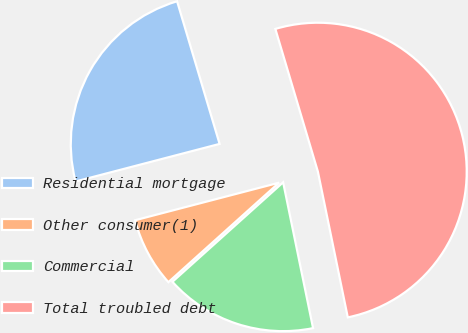Convert chart to OTSL. <chart><loc_0><loc_0><loc_500><loc_500><pie_chart><fcel>Residential mortgage<fcel>Other consumer(1)<fcel>Commercial<fcel>Total troubled debt<nl><fcel>24.45%<fcel>7.59%<fcel>16.57%<fcel>51.39%<nl></chart> 